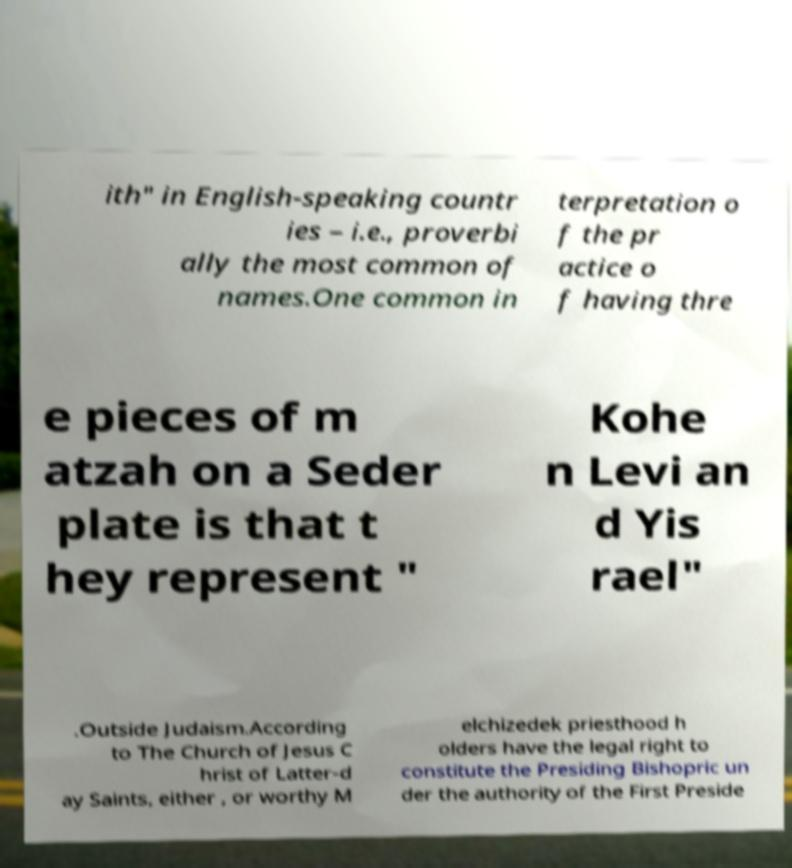Can you read and provide the text displayed in the image?This photo seems to have some interesting text. Can you extract and type it out for me? ith" in English-speaking countr ies – i.e., proverbi ally the most common of names.One common in terpretation o f the pr actice o f having thre e pieces of m atzah on a Seder plate is that t hey represent " Kohe n Levi an d Yis rael" .Outside Judaism.According to The Church of Jesus C hrist of Latter-d ay Saints, either , or worthy M elchizedek priesthood h olders have the legal right to constitute the Presiding Bishopric un der the authority of the First Preside 